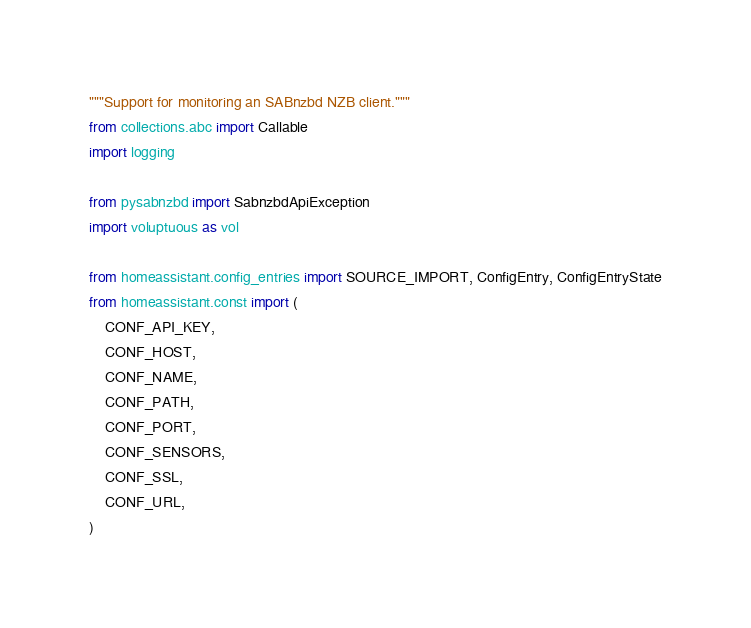<code> <loc_0><loc_0><loc_500><loc_500><_Python_>"""Support for monitoring an SABnzbd NZB client."""
from collections.abc import Callable
import logging

from pysabnzbd import SabnzbdApiException
import voluptuous as vol

from homeassistant.config_entries import SOURCE_IMPORT, ConfigEntry, ConfigEntryState
from homeassistant.const import (
    CONF_API_KEY,
    CONF_HOST,
    CONF_NAME,
    CONF_PATH,
    CONF_PORT,
    CONF_SENSORS,
    CONF_SSL,
    CONF_URL,
)</code> 